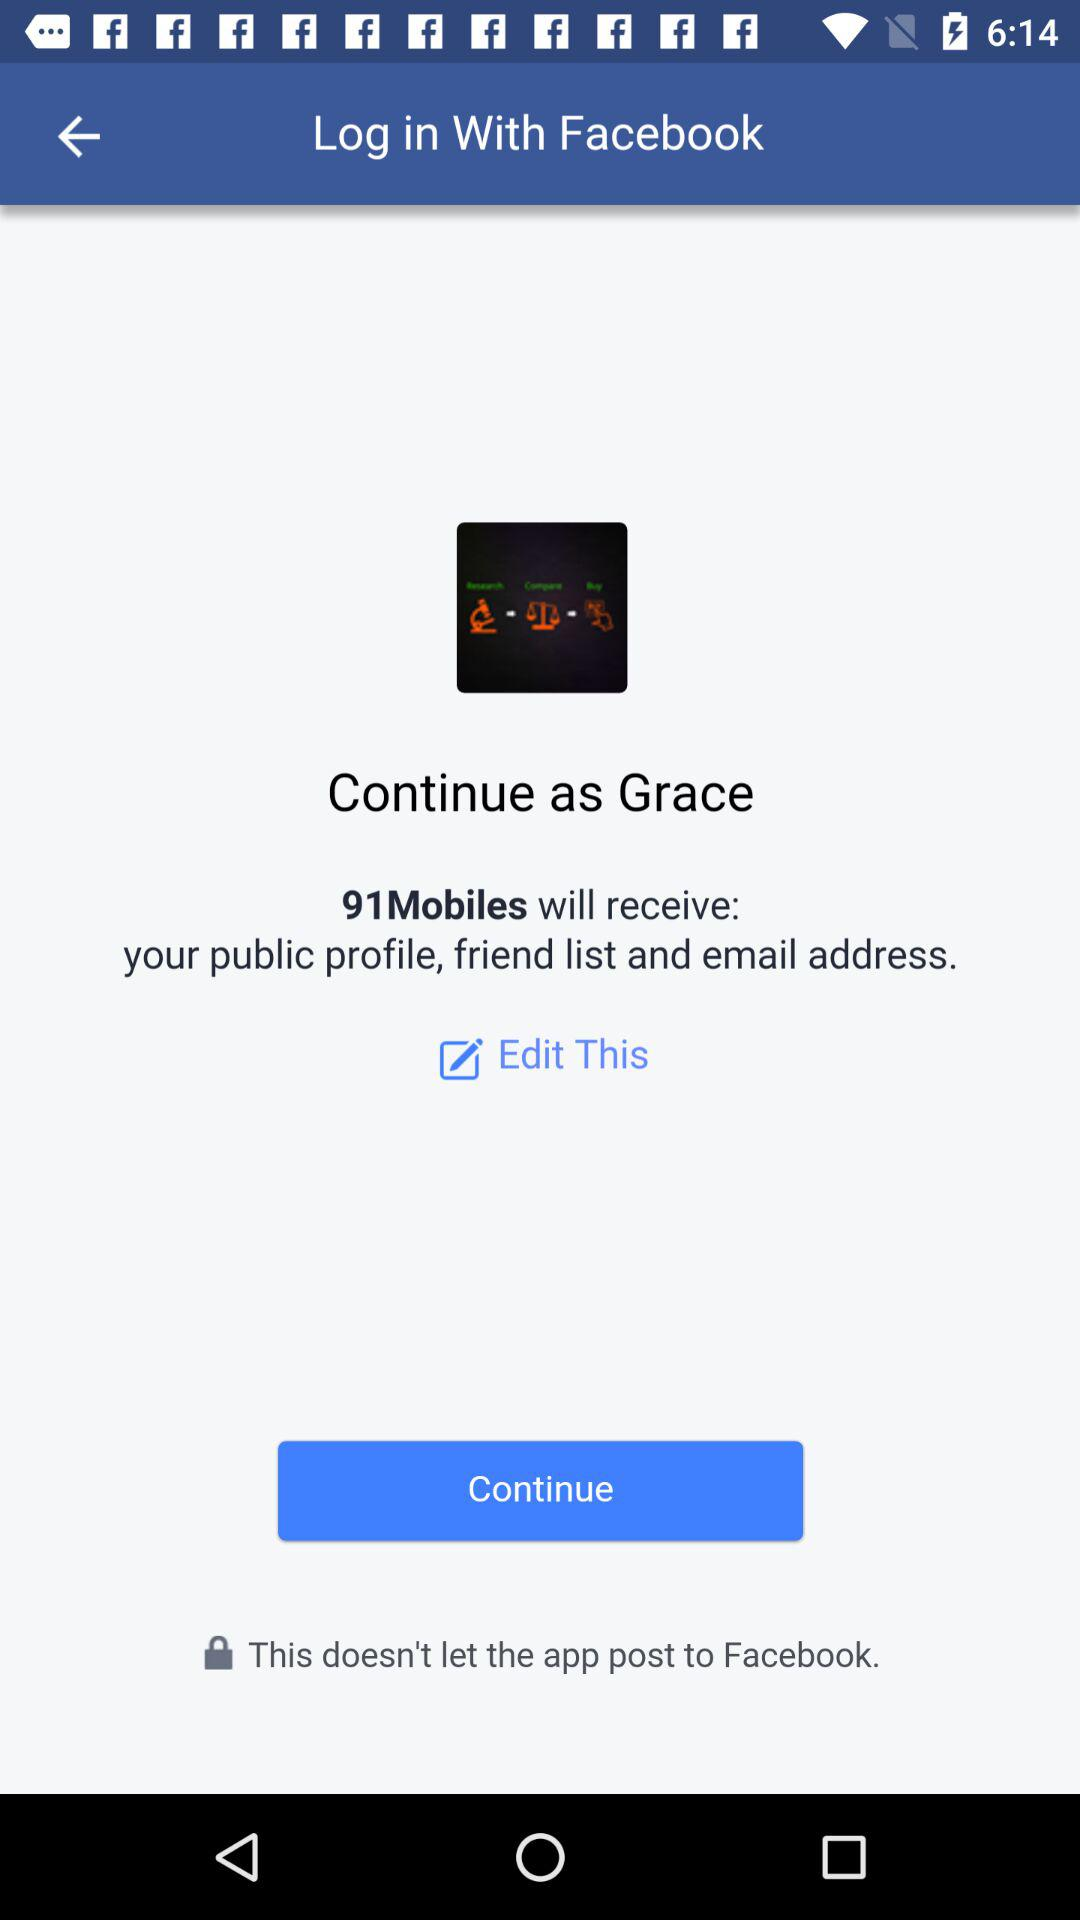What application will receive the public profile, friend list and email address? The application "91Mobiles" will receive the public profile, friend list and email address. 